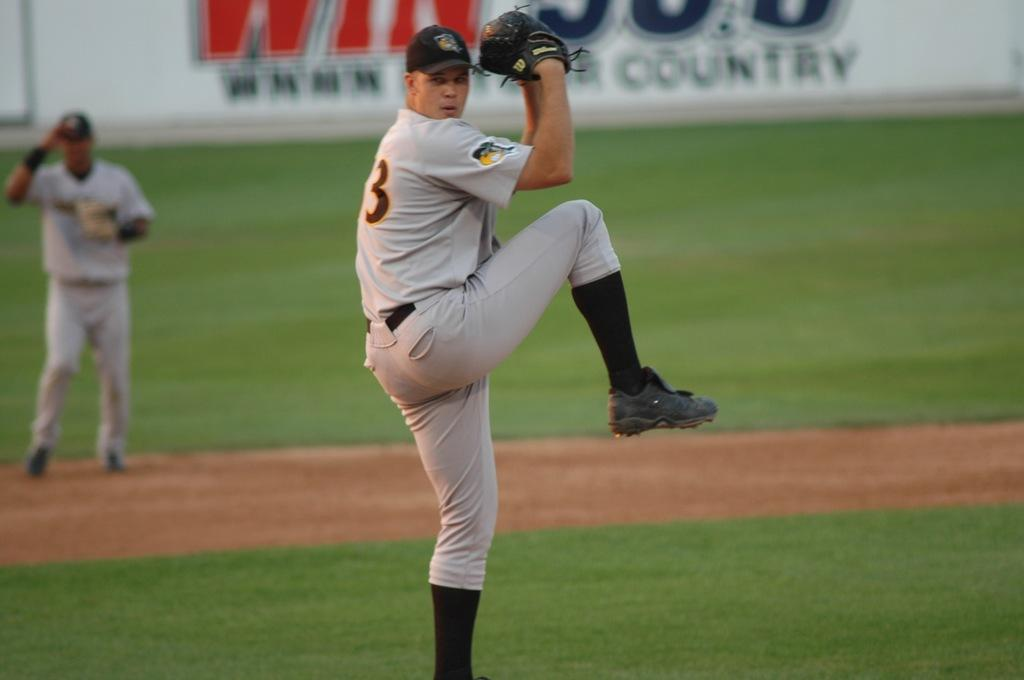<image>
Write a terse but informative summary of the picture. The glove the pitcher is wearing is made by Wilson. 